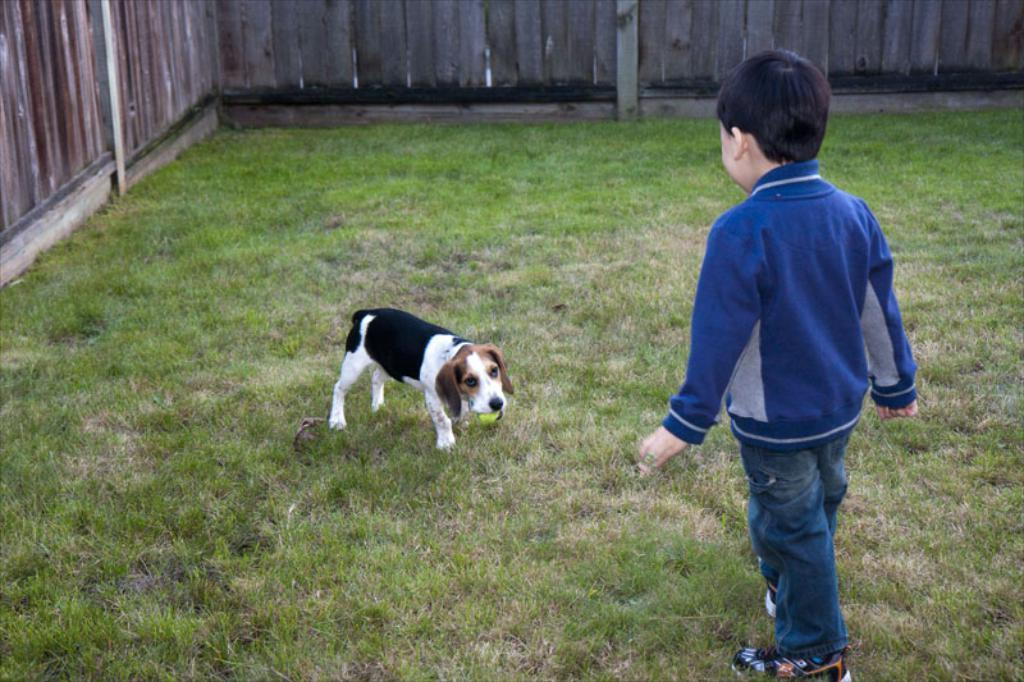What is the primary feature of the land in the image? The land is covered with grass. What animal can be seen in the image? There is a dog in the image. What is the dog doing in the image? The dog is holding a ball in its mouth. What is surrounding the grass in the image? There is a fence surrounding the grass. What role does the dog play in the image? The dog is not playing a role in the image; it is simply holding a ball in its mouth. How many stars can be seen in the image? There are no stars visible in the image, as it features a dog holding a ball on a grassy area surrounded by a fence. 